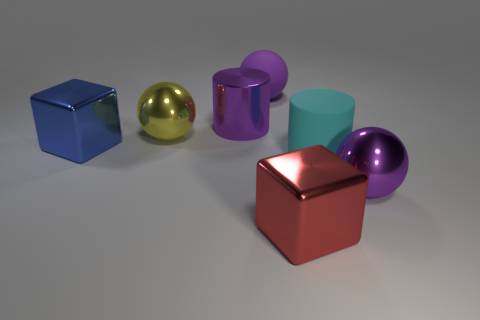Add 3 large brown metallic cubes. How many objects exist? 10 Subtract all cubes. How many objects are left? 5 Add 6 tiny red matte cylinders. How many tiny red matte cylinders exist? 6 Subtract 0 brown blocks. How many objects are left? 7 Subtract all tiny purple cylinders. Subtract all large yellow metal things. How many objects are left? 6 Add 3 red cubes. How many red cubes are left? 4 